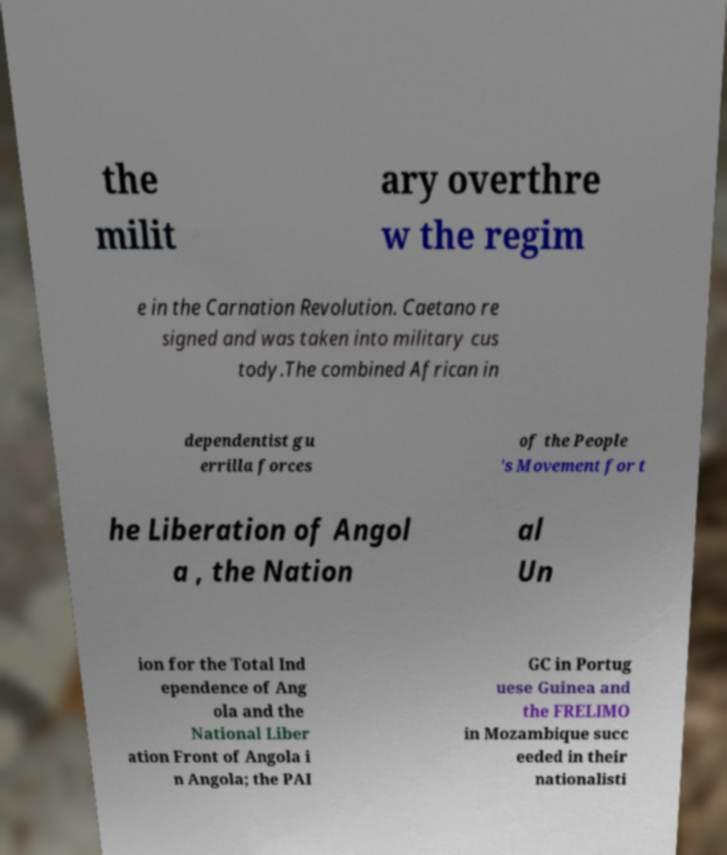There's text embedded in this image that I need extracted. Can you transcribe it verbatim? the milit ary overthre w the regim e in the Carnation Revolution. Caetano re signed and was taken into military cus tody.The combined African in dependentist gu errilla forces of the People 's Movement for t he Liberation of Angol a , the Nation al Un ion for the Total Ind ependence of Ang ola and the National Liber ation Front of Angola i n Angola; the PAI GC in Portug uese Guinea and the FRELIMO in Mozambique succ eeded in their nationalisti 